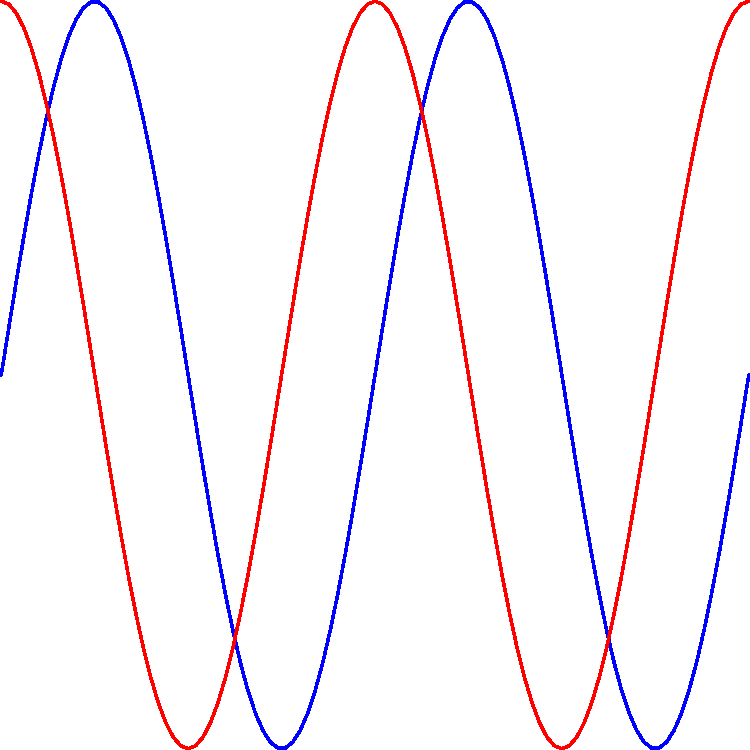In the context of political speeches, consider the wave interference pattern shown above. Speech A (blue) and Speech B (red) are given simultaneously, resulting in the combined wave (green). If these represent the emotional impact of the speeches over time, what political strategy might this interference pattern suggest for maximizing audience engagement? To analyze this situation, let's break it down step-by-step:

1. Wave Characteristics:
   - Speech A (blue) and Speech B (red) have the same frequency but are out of phase by $\frac{\pi}{2}$ radians (quarter cycle).
   - The combined wave (green) is the result of constructive and destructive interference.

2. Interference Pattern:
   - At points where both waves have positive or negative values, constructive interference occurs, amplifying the emotional impact.
   - Where one wave is positive and the other negative, destructive interference reduces the overall impact.

3. Political Strategy Implications:
   - The combined wave has a higher peak amplitude than either individual speech, suggesting moments of heightened emotional impact.
   - The pattern repeats regularly, indicating a rhythmic fluctuation in audience engagement.

4. Maximizing Engagement:
   - Coordinate the speeches to align their key points with the peaks of the combined wave.
   - Use the interference pattern to create a dynamic ebb and flow in the overall presentation.
   - During destructive interference periods, introduce supporting elements (e.g., visual aids, audience participation) to maintain engagement.

5. Timing and Pacing:
   - Structure the speeches so that critical messages coincide with constructive interference peaks.
   - Use the periods of lower amplitude for transitions or less crucial information.

6. Overall Strategy:
   - This approach creates a "harmonic political discourse" where the interplay between speeches enhances the overall impact and maintains audience attention through varied emotional intensity.
Answer: Coordinate key points with interference peaks, use rhythm for engagement, and balance content with wave dynamics. 